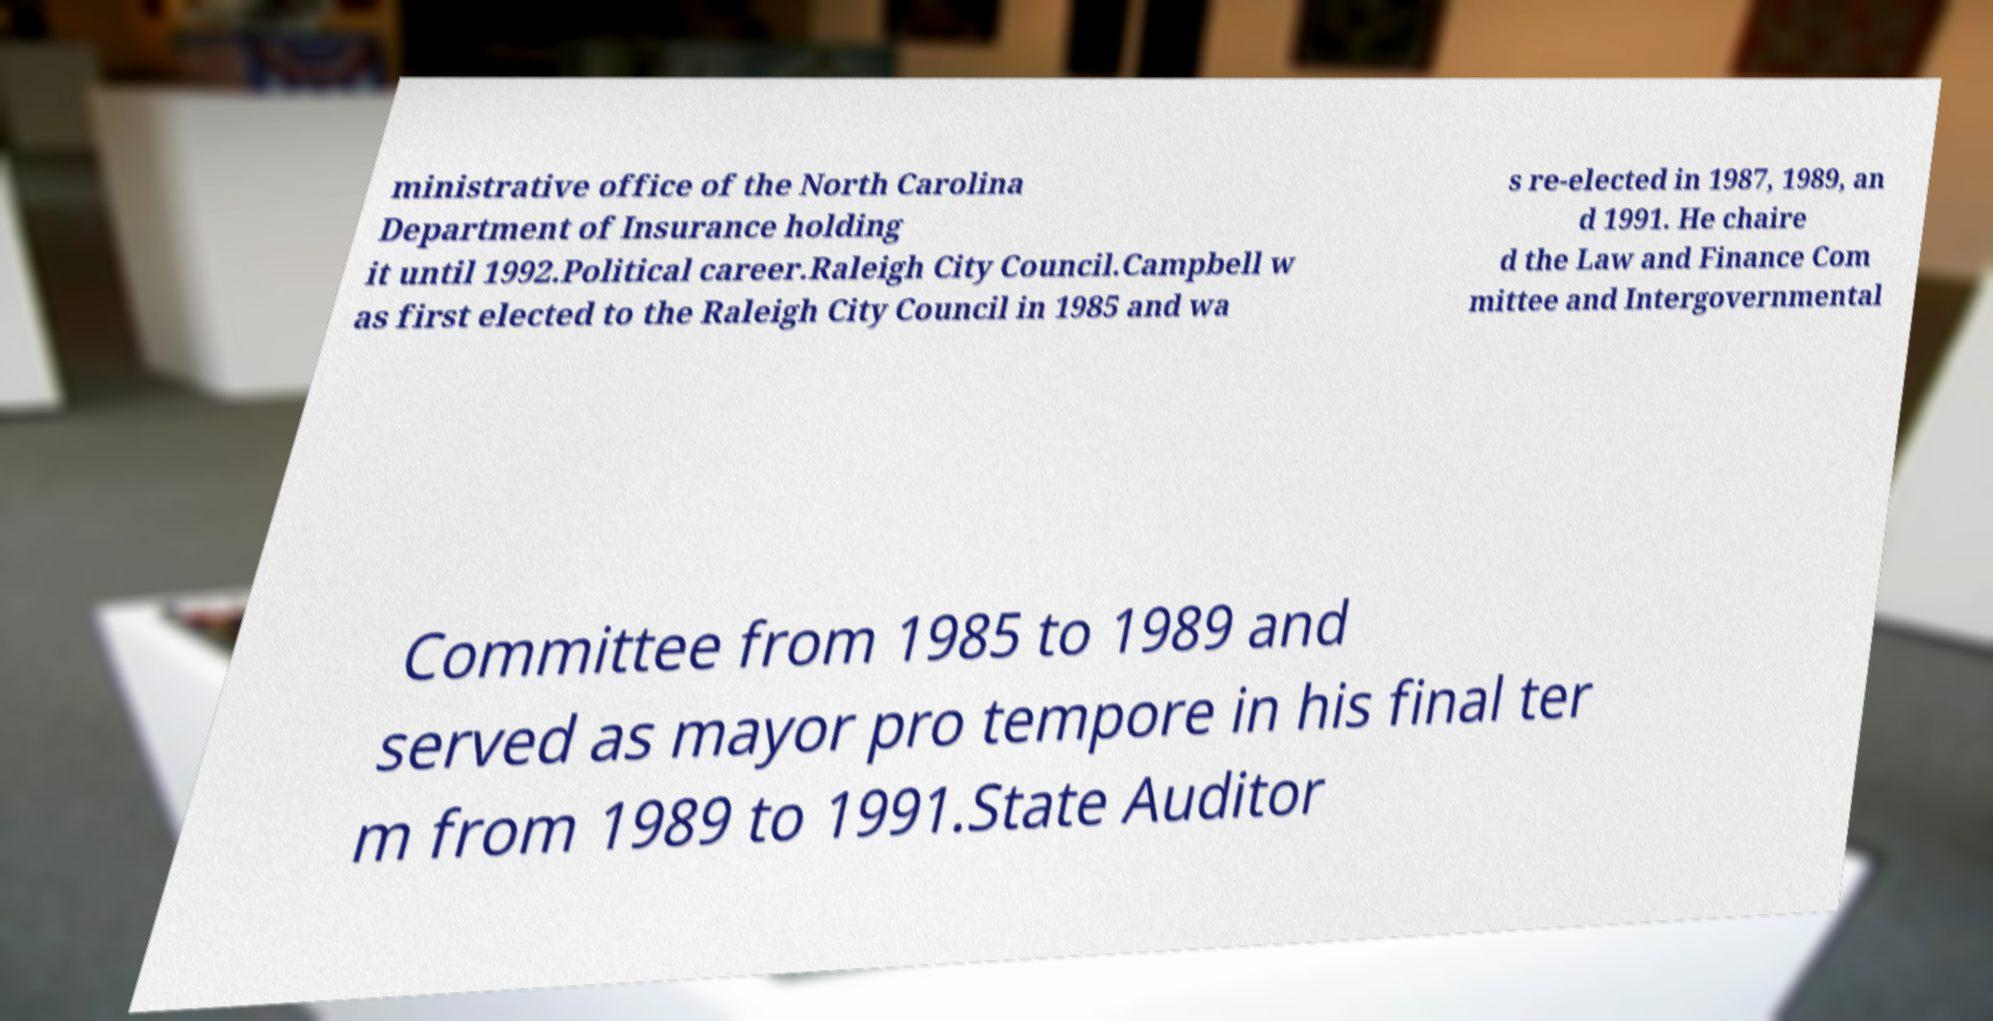Please identify and transcribe the text found in this image. ministrative office of the North Carolina Department of Insurance holding it until 1992.Political career.Raleigh City Council.Campbell w as first elected to the Raleigh City Council in 1985 and wa s re-elected in 1987, 1989, an d 1991. He chaire d the Law and Finance Com mittee and Intergovernmental Committee from 1985 to 1989 and served as mayor pro tempore in his final ter m from 1989 to 1991.State Auditor 